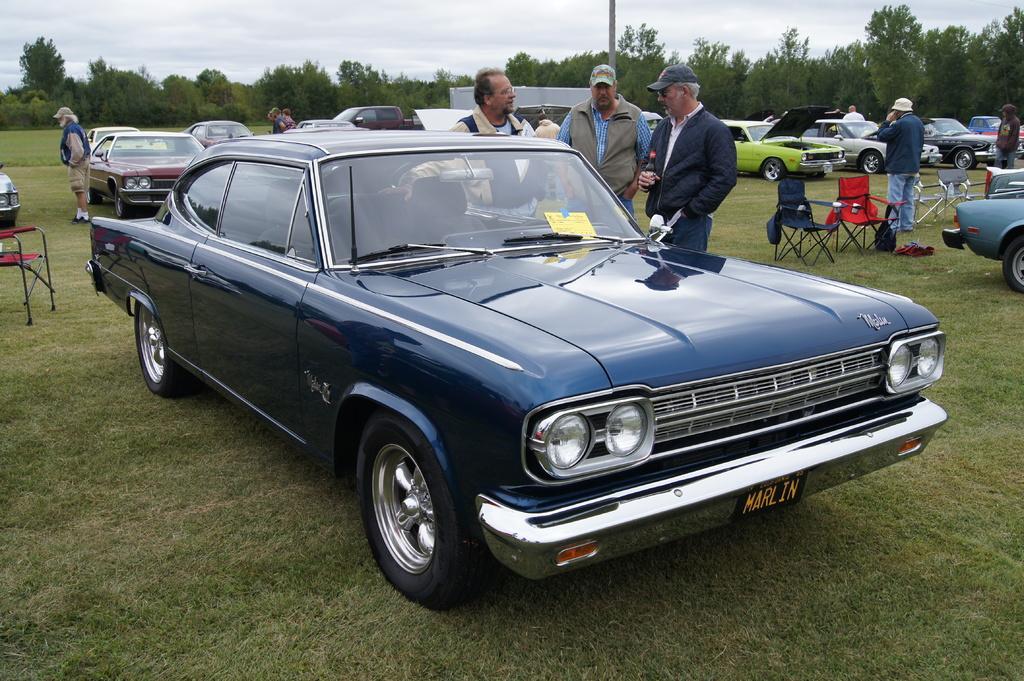In one or two sentences, can you explain what this image depicts? In this picture there are vehicles and there are group of people standing and there are chairs. At the back there are trees and there is a tent and pole. At the top there is sky and there are clouds. At the bottom there is grass. 